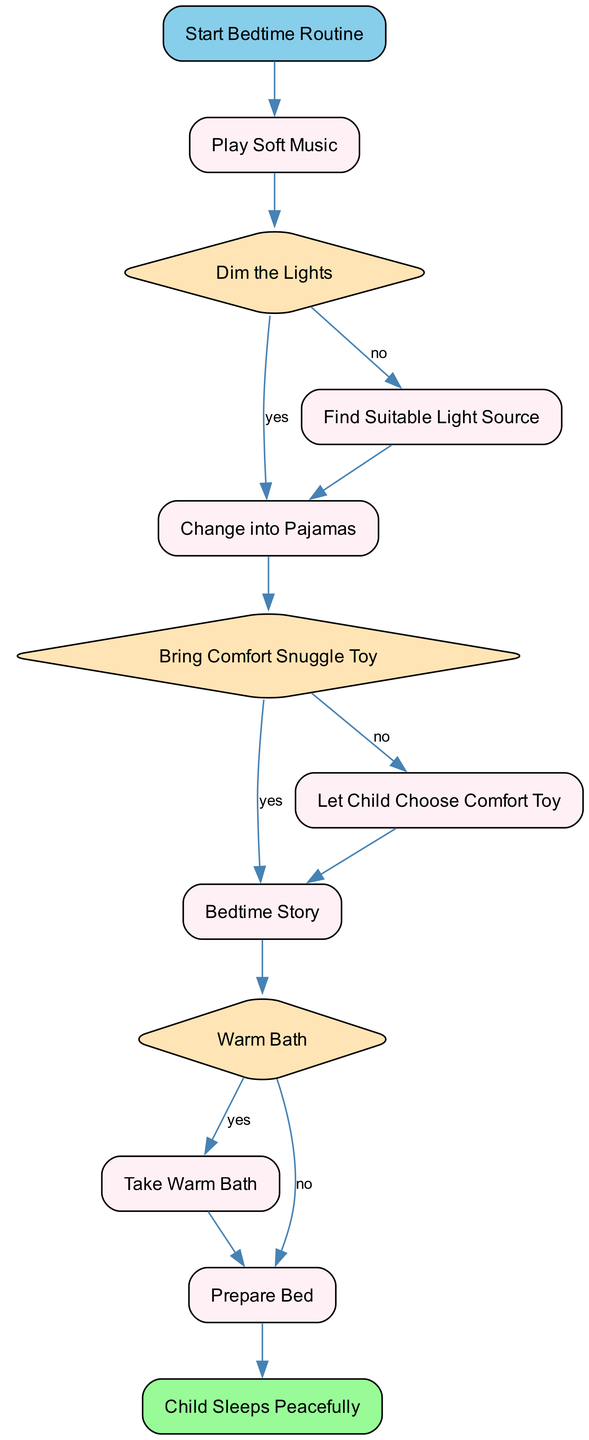what is the first step in the bedtime routine? The first step in the diagram is labeled "Start Bedtime Routine," which signifies the beginning of the process.
Answer: Start Bedtime Routine how many decision nodes are in the diagram? The diagram features three decision nodes: "Dim the Lights," "Bring Comfort Snuggle Toy," and "Warm Bath." Hence, the total count is three.
Answer: 3 what follows after changing into pajamas? After changing into pajamas, the next step is the decision node "Bring Comfort Snuggle Toy." This indicates that the next action depends on whether or not a comfort toy is brought.
Answer: Bring Comfort Snuggle Toy what happens if the lights are dimmed? If the lights are dimmed ("yes" condition), the next step is "Change into Pajamas," indicating that dimming the lights results in changing into pajamas.
Answer: Change into Pajamas if a child does not bring a comfort toy, what is the next step? If a comfort toy is not brought, the child must "choose toy," which allows the child to select their favorite soft toy or blanket, as indicated by the decision node "Bring Comfort Snuggle Toy."
Answer: Choose Toy what is the final step in the bedtime routine? The last step in the diagram is labeled "Child Sleeps Peacefully," which indicates that the final outcome of the routine is the child sleeping well.
Answer: Child Sleeps Peacefully which step comes before "Take Warm Bath"? The step that comes before "Take Warm Bath" is the decision node "Warm Bath," where a decision must be made to either take a bath or proceed to "Prepare Bed."
Answer: Warm Bath how many processes are indicated in the diagram? The diagram includes five process nodes: "Play Soft Music," "Find Suitable Light Source," "Change into Pajamas," "Bedtime Story," and "Prepare Bed." This totals to five processes.
Answer: 5 